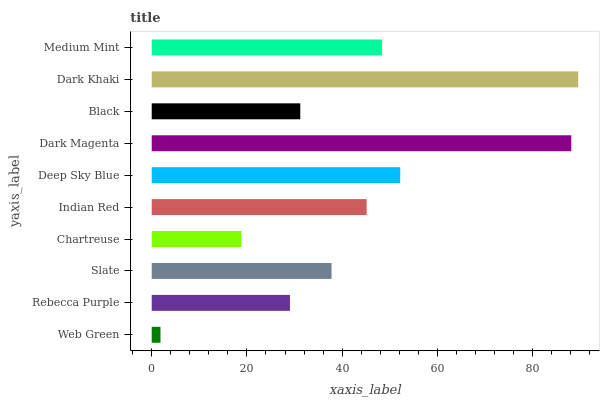Is Web Green the minimum?
Answer yes or no. Yes. Is Dark Khaki the maximum?
Answer yes or no. Yes. Is Rebecca Purple the minimum?
Answer yes or no. No. Is Rebecca Purple the maximum?
Answer yes or no. No. Is Rebecca Purple greater than Web Green?
Answer yes or no. Yes. Is Web Green less than Rebecca Purple?
Answer yes or no. Yes. Is Web Green greater than Rebecca Purple?
Answer yes or no. No. Is Rebecca Purple less than Web Green?
Answer yes or no. No. Is Indian Red the high median?
Answer yes or no. Yes. Is Slate the low median?
Answer yes or no. Yes. Is Dark Magenta the high median?
Answer yes or no. No. Is Dark Magenta the low median?
Answer yes or no. No. 